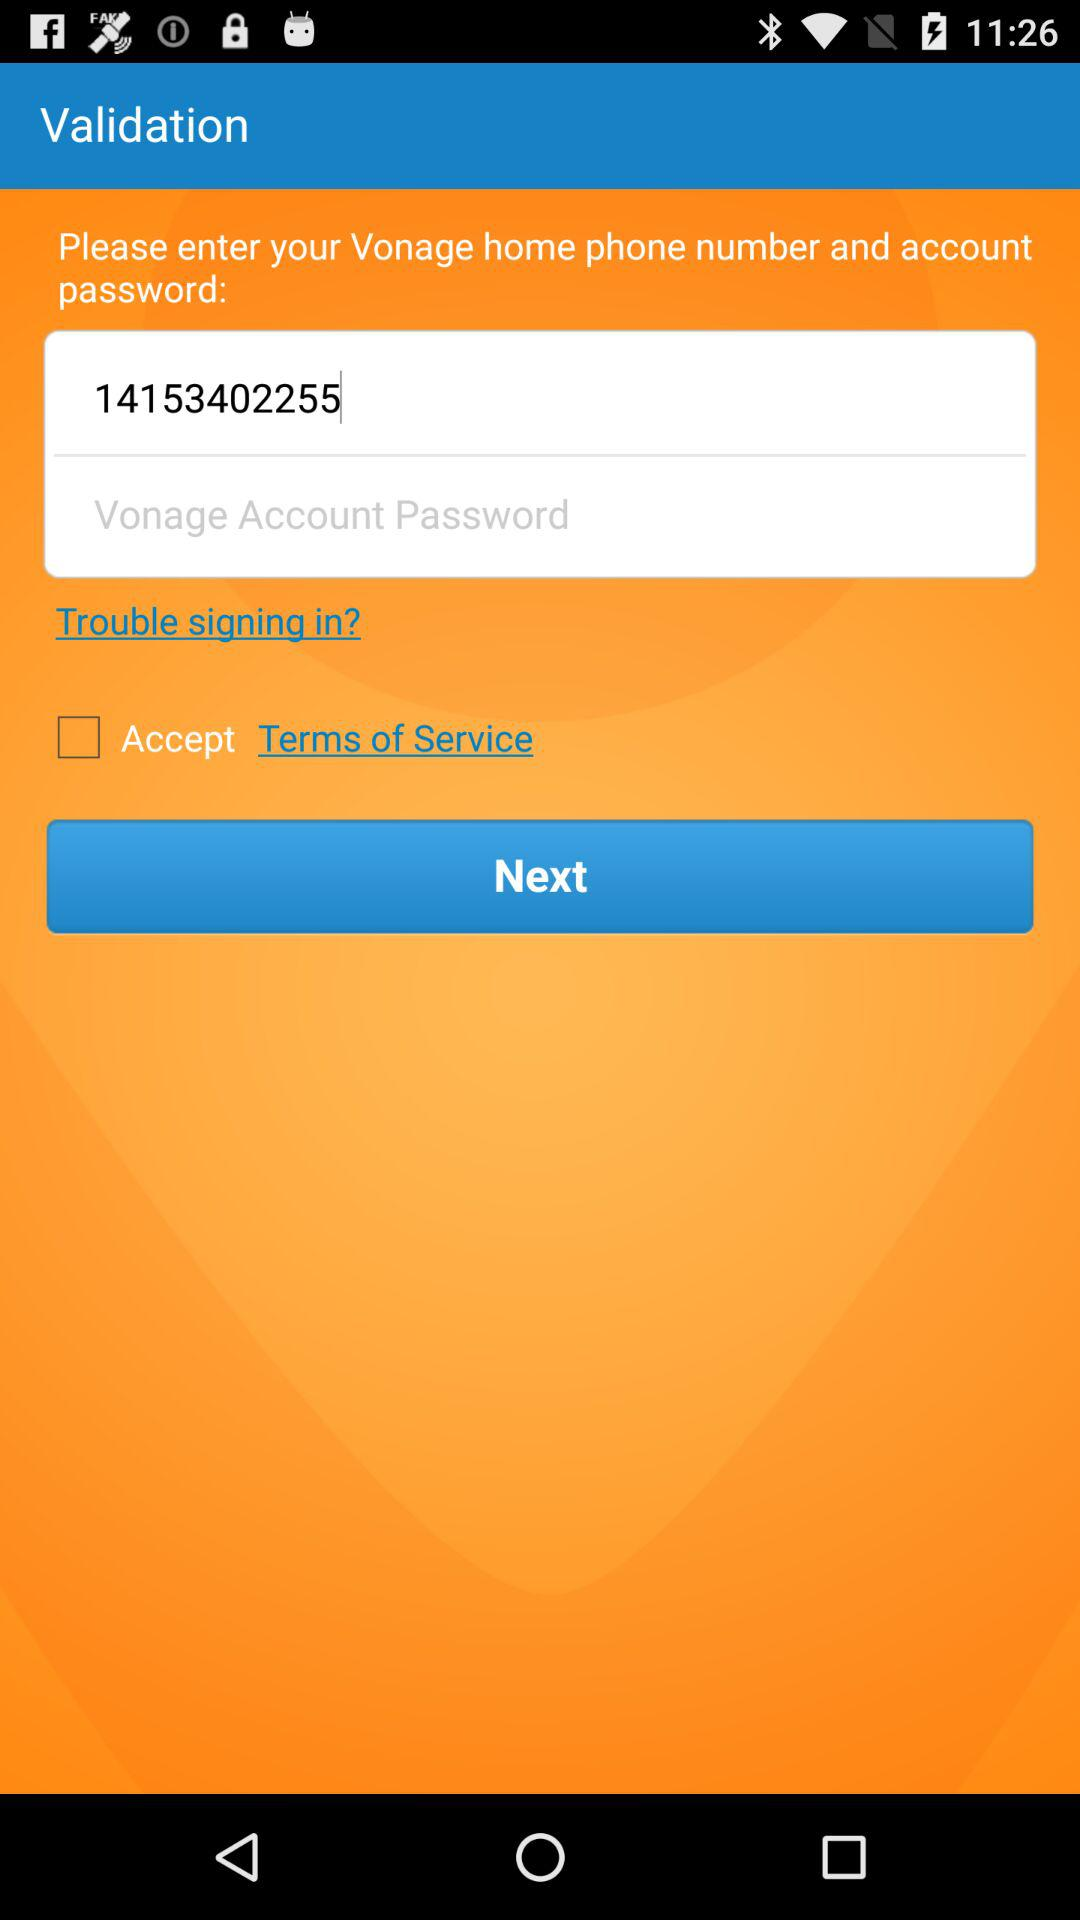What is the status of "Accept terms of service"? The status is "off". 